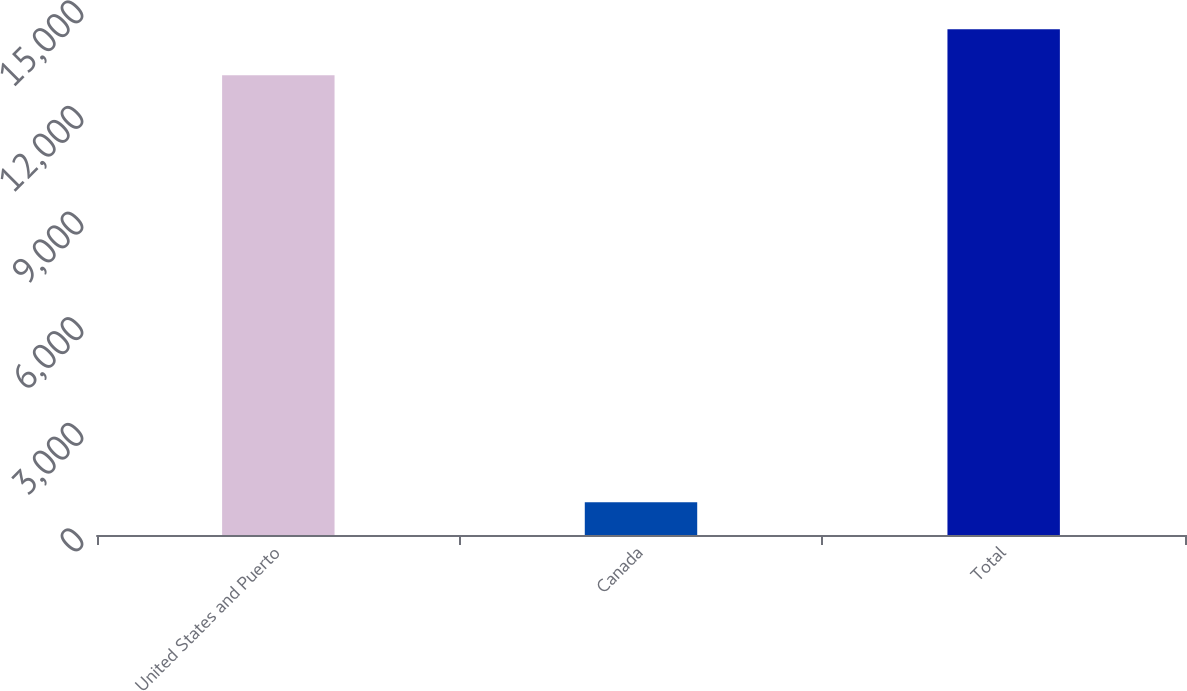Convert chart. <chart><loc_0><loc_0><loc_500><loc_500><bar_chart><fcel>United States and Puerto<fcel>Canada<fcel>Total<nl><fcel>13064<fcel>932<fcel>14370.4<nl></chart> 